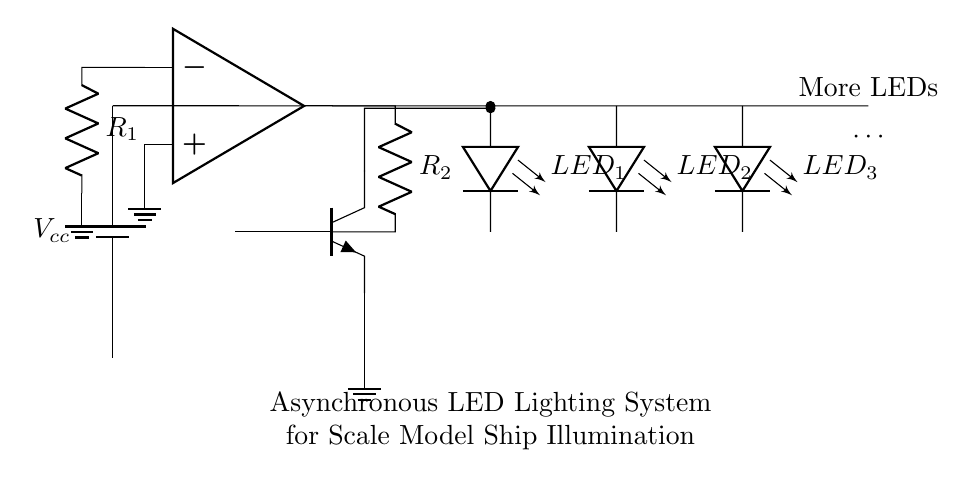What type of transistor is used in the circuit? The circuit shows an NPN transistor, which can be identified by the labeling and the symbol displayed in the diagram. The three terminals are labeled with B for base, E for emitter, and C for collector, which is characteristic of an NPN transistor.
Answer: NPN What components are connected to the LED array? The LED array consists of three LEDs, labeled LED_1, LED_2, and LED_3. Additionally, there is a label indicating that more LEDs can be added, which implies they can be connected in parallel with the existing ones.
Answer: LED_1, LED_2, LED_3 What is the function of the operational amplifier in this circuit? The operational amplifier acts as a comparator in the asynchronous control circuit. It compares the input voltage at its non-inverting terminal with the input voltage at its inverting terminal, allowing it to control the switching of the NPN transistor and ultimately the LED illumination based on the input signals.
Answer: Comparator How many resistors are present in this circuit? The circuit diagram shows two resistors, R_1 and R_2, which are connected to the operational amplifier and play a vital role in controlling the circuit behavior.
Answer: 2 What does the ground symbol represent in the circuit? The ground symbol indicates a common reference point for the circuit voltages and serves as the return path for the current. All components needing a ground connection are linked to this point to ensure proper circuit operation.
Answer: Common reference What triggers the illumination of the LEDs in the circuit? The illumination of the LEDs is triggered by the state of the NPN transistor. When a sufficient voltage is applied to the base of the transistor through the operational amplifier, it turns on, allowing current to flow through the LED array and thus illuminating them.
Answer: Base voltage 